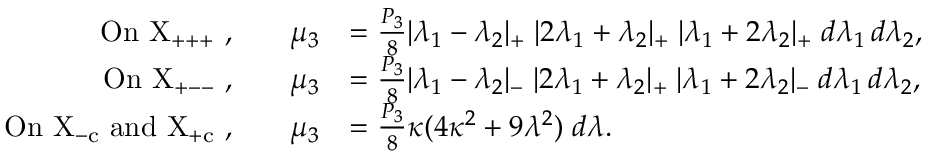Convert formula to latex. <formula><loc_0><loc_0><loc_500><loc_500>\begin{array} { r l r l } { O n X _ { + + + } , } & { \mu _ { 3 } } & { = \frac { P _ { 3 } } { 8 } | \lambda _ { 1 } - \lambda _ { 2 } | _ { + } \, | 2 \lambda _ { 1 } + \lambda _ { 2 } | _ { + } \, | \lambda _ { 1 } + 2 \lambda _ { 2 } | _ { + } \, d \lambda _ { 1 } \, d \lambda _ { 2 } , } \\ { O n X _ { + - - } , } & { \mu _ { 3 } } & { = \frac { P _ { 3 } } { 8 } | \lambda _ { 1 } - \lambda _ { 2 } | _ { - } \, | 2 \lambda _ { 1 } + \lambda _ { 2 } | _ { + } \, | \lambda _ { 1 } + 2 \lambda _ { 2 } | _ { - } \, d \lambda _ { 1 } \, d \lambda _ { 2 } , } \\ { O n X _ { - c } a n d X _ { + c } , } & { \mu _ { 3 } } & { = \frac { P _ { 3 } } { 8 } \kappa ( 4 \kappa ^ { 2 } + 9 \lambda ^ { 2 } ) \, d \lambda . } \end{array}</formula> 